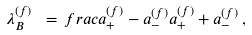<formula> <loc_0><loc_0><loc_500><loc_500>\lambda _ { B } ^ { ( f ) } \ = \, f r a c { a _ { + } ^ { ( f ) } - a _ { - } ^ { ( f ) } } { a _ { + } ^ { ( f ) } + a _ { - } ^ { ( f ) } } \, ,</formula> 